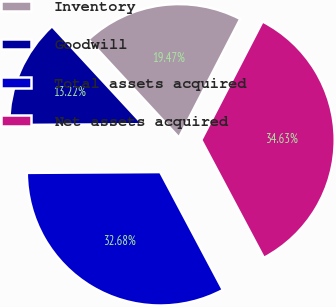Convert chart. <chart><loc_0><loc_0><loc_500><loc_500><pie_chart><fcel>Inventory<fcel>Goodwill<fcel>Total assets acquired<fcel>Net assets acquired<nl><fcel>19.47%<fcel>13.22%<fcel>32.68%<fcel>34.63%<nl></chart> 